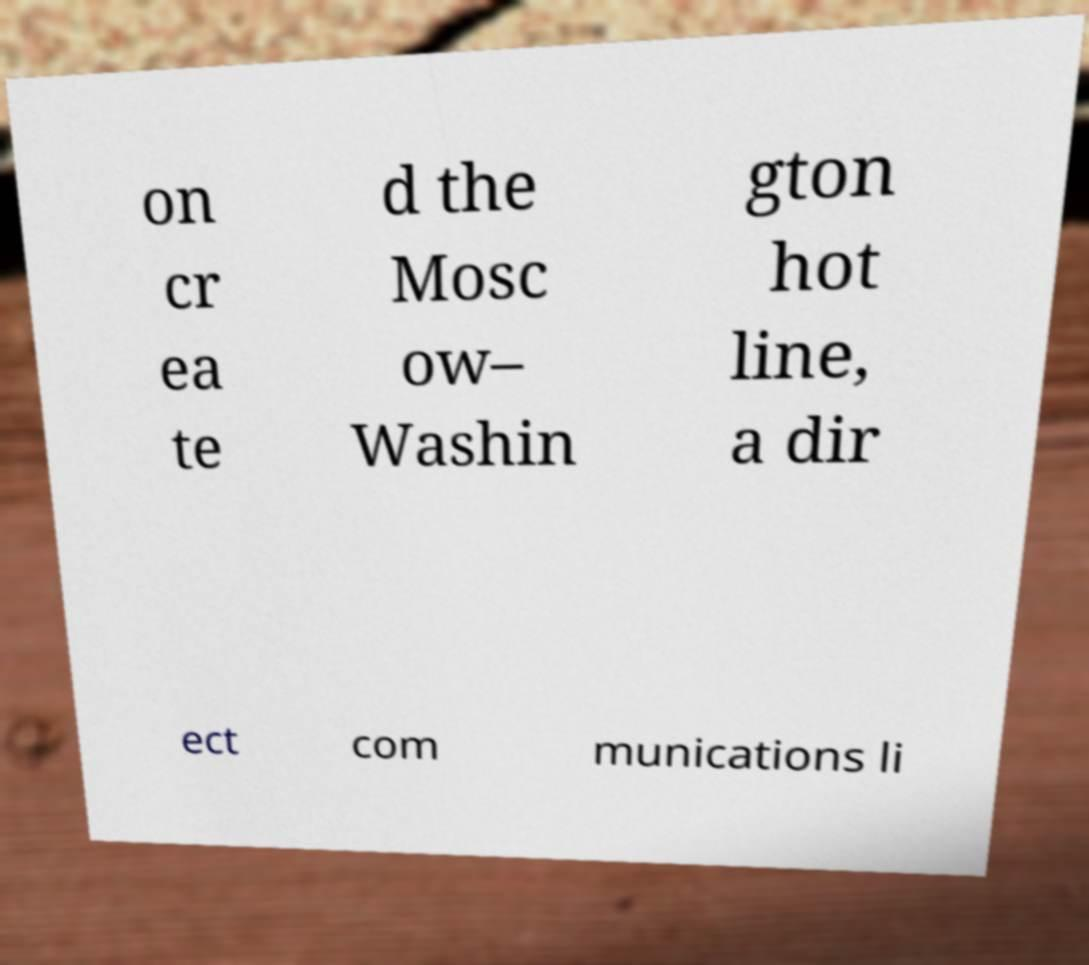Can you read and provide the text displayed in the image?This photo seems to have some interesting text. Can you extract and type it out for me? on cr ea te d the Mosc ow– Washin gton hot line, a dir ect com munications li 